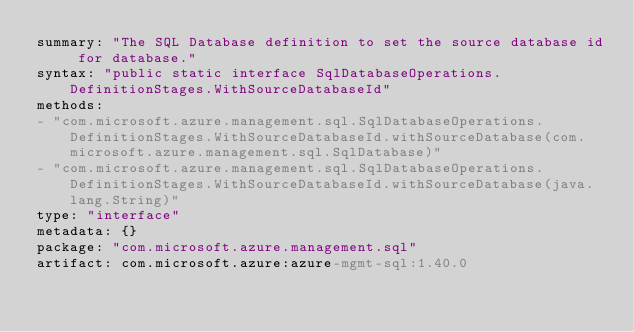<code> <loc_0><loc_0><loc_500><loc_500><_YAML_>summary: "The SQL Database definition to set the source database id for database."
syntax: "public static interface SqlDatabaseOperations.DefinitionStages.WithSourceDatabaseId"
methods:
- "com.microsoft.azure.management.sql.SqlDatabaseOperations.DefinitionStages.WithSourceDatabaseId.withSourceDatabase(com.microsoft.azure.management.sql.SqlDatabase)"
- "com.microsoft.azure.management.sql.SqlDatabaseOperations.DefinitionStages.WithSourceDatabaseId.withSourceDatabase(java.lang.String)"
type: "interface"
metadata: {}
package: "com.microsoft.azure.management.sql"
artifact: com.microsoft.azure:azure-mgmt-sql:1.40.0
</code> 